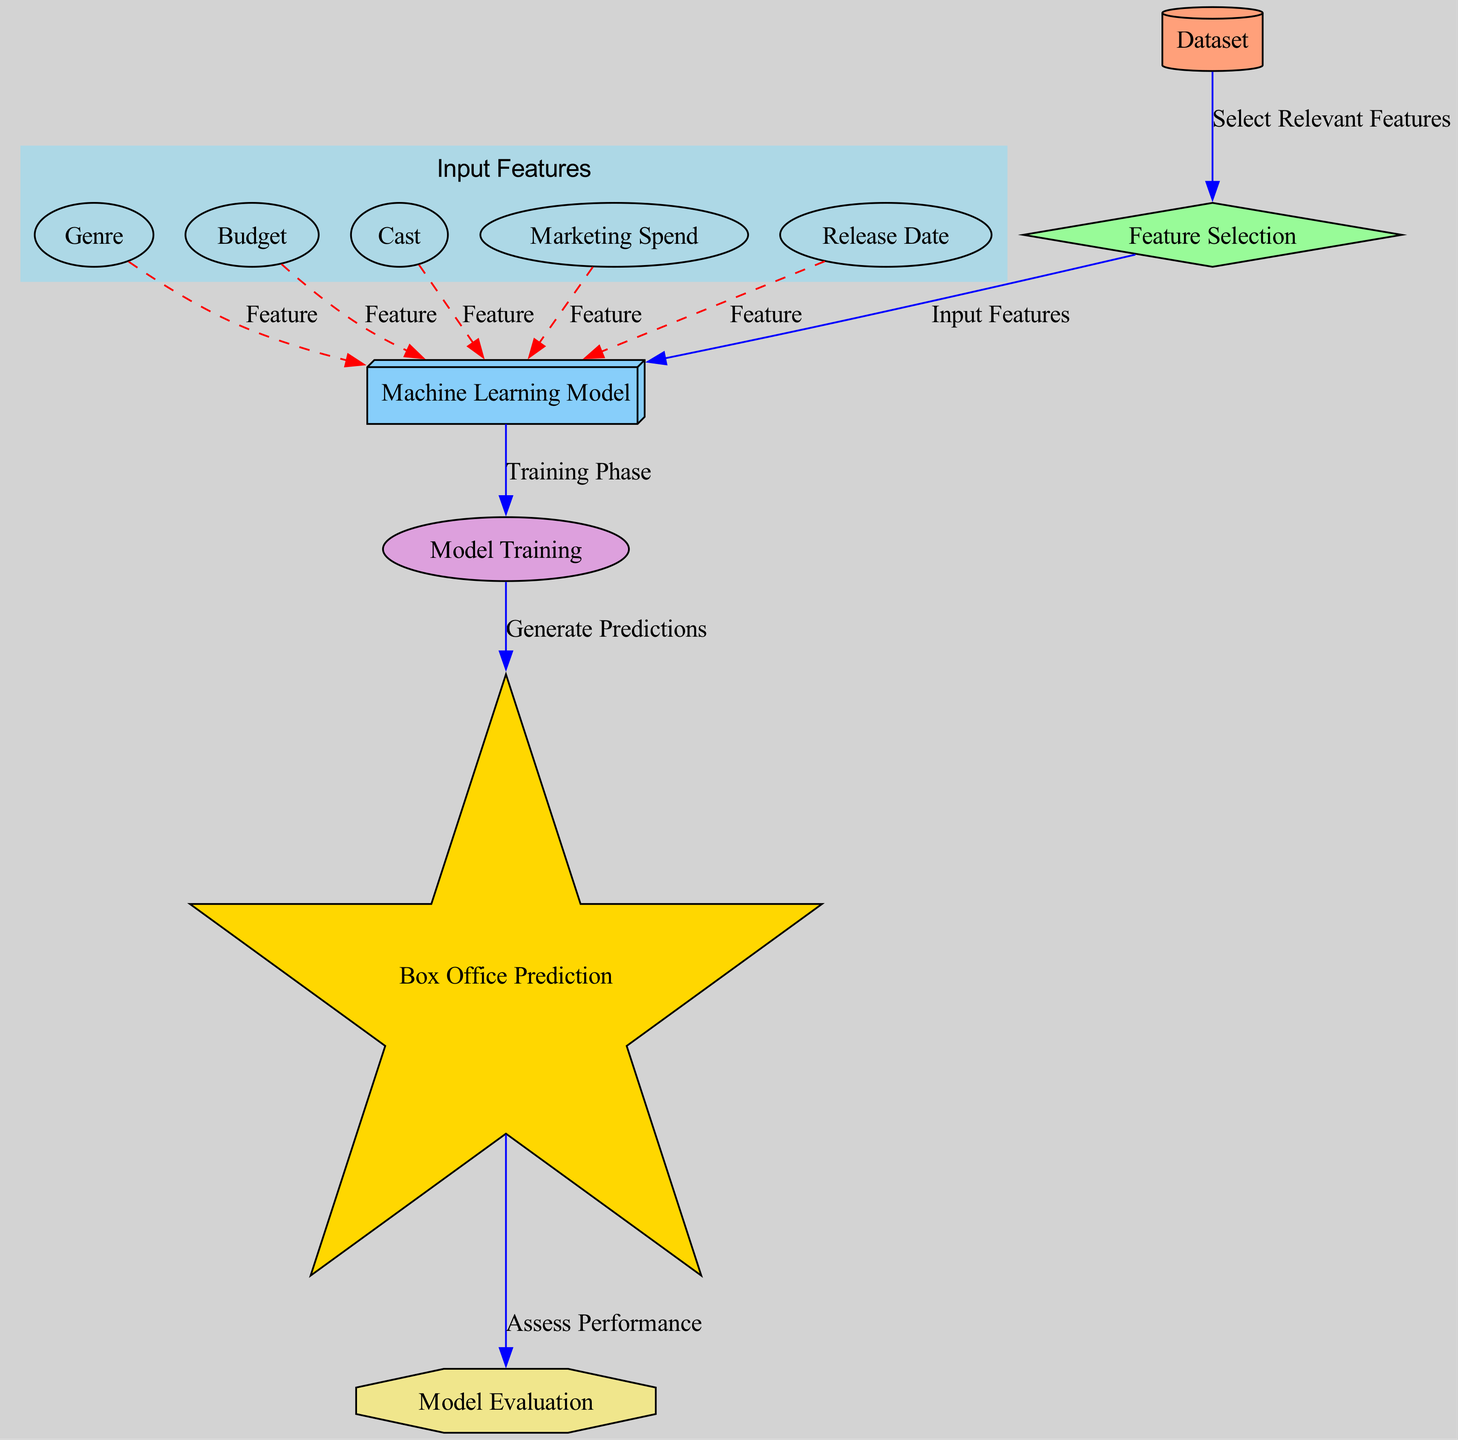What is the main output of the machine learning model? The main output represented in the diagram is "Box Office Prediction", which indicates the earnings predicted by the model.
Answer: Box Office Prediction How many input features are shown in the diagram? The diagram displays five input features, corresponding to genre, budget, cast, marketing spend, and release date.
Answer: Five Which node represents the evaluation of the model's performance? The node called "Model Evaluation" is where the performance of the machine learning model is assessed using evaluation metrics.
Answer: Model Evaluation What type of algorithm is used for the prediction in this diagram? The diagram specifies that a "Machine Learning Model" like a Random Forest is utilized for making predictions about box office earnings.
Answer: Machine Learning Model What is the process that selects relevant features for the ML model? The diagram indicates "Feature Selection" as the process used to choose relevant features before they are inputted into the machine learning model.
Answer: Feature Selection How does the model generating predictions connect to the evaluation? The connection is established by the edge labeled "Assess Performance", which signifies that predictions generated by the model are then evaluated for their accuracy.
Answer: Assess Performance Which node appears to influence the prediction of box office earnings the most? The diagram does not specify weights for each feature, but all input features (genre, budget, cast, marketing spend, release date) have edges indicating they influence predictions; it's subjective which has the most influence based on the context of the data.
Answer: Subjective What is the shape of the node representing the dataset? The dataset is represented with a cylindrical shape, signifying its foundational role in the modeling process.
Answer: Cylinder In what phase is the ML Model utilized according to the diagram? The ML Model is utilized in the "Training Phase", which is part of the model training process where the model learns from the dataset.
Answer: Training Phase 